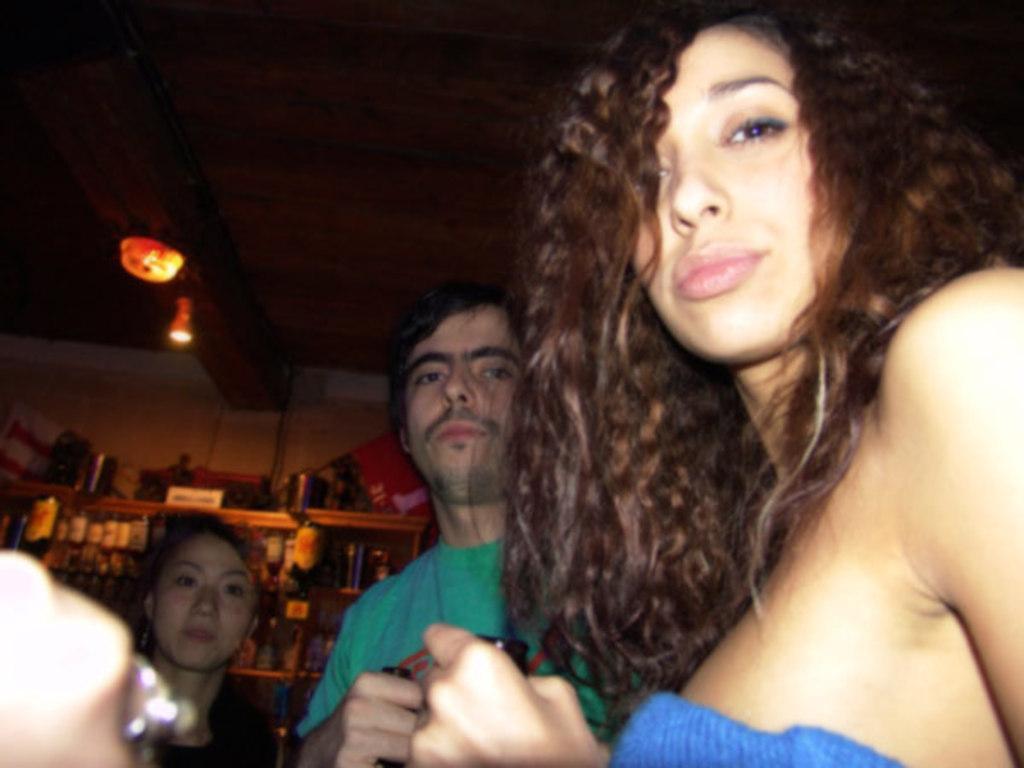Could you give a brief overview of what you see in this image? In this picture I can see few people and few bottles in the shelves and I can see couple of lights on the ceiling and I can see couple of them holding bottles in their hands. 